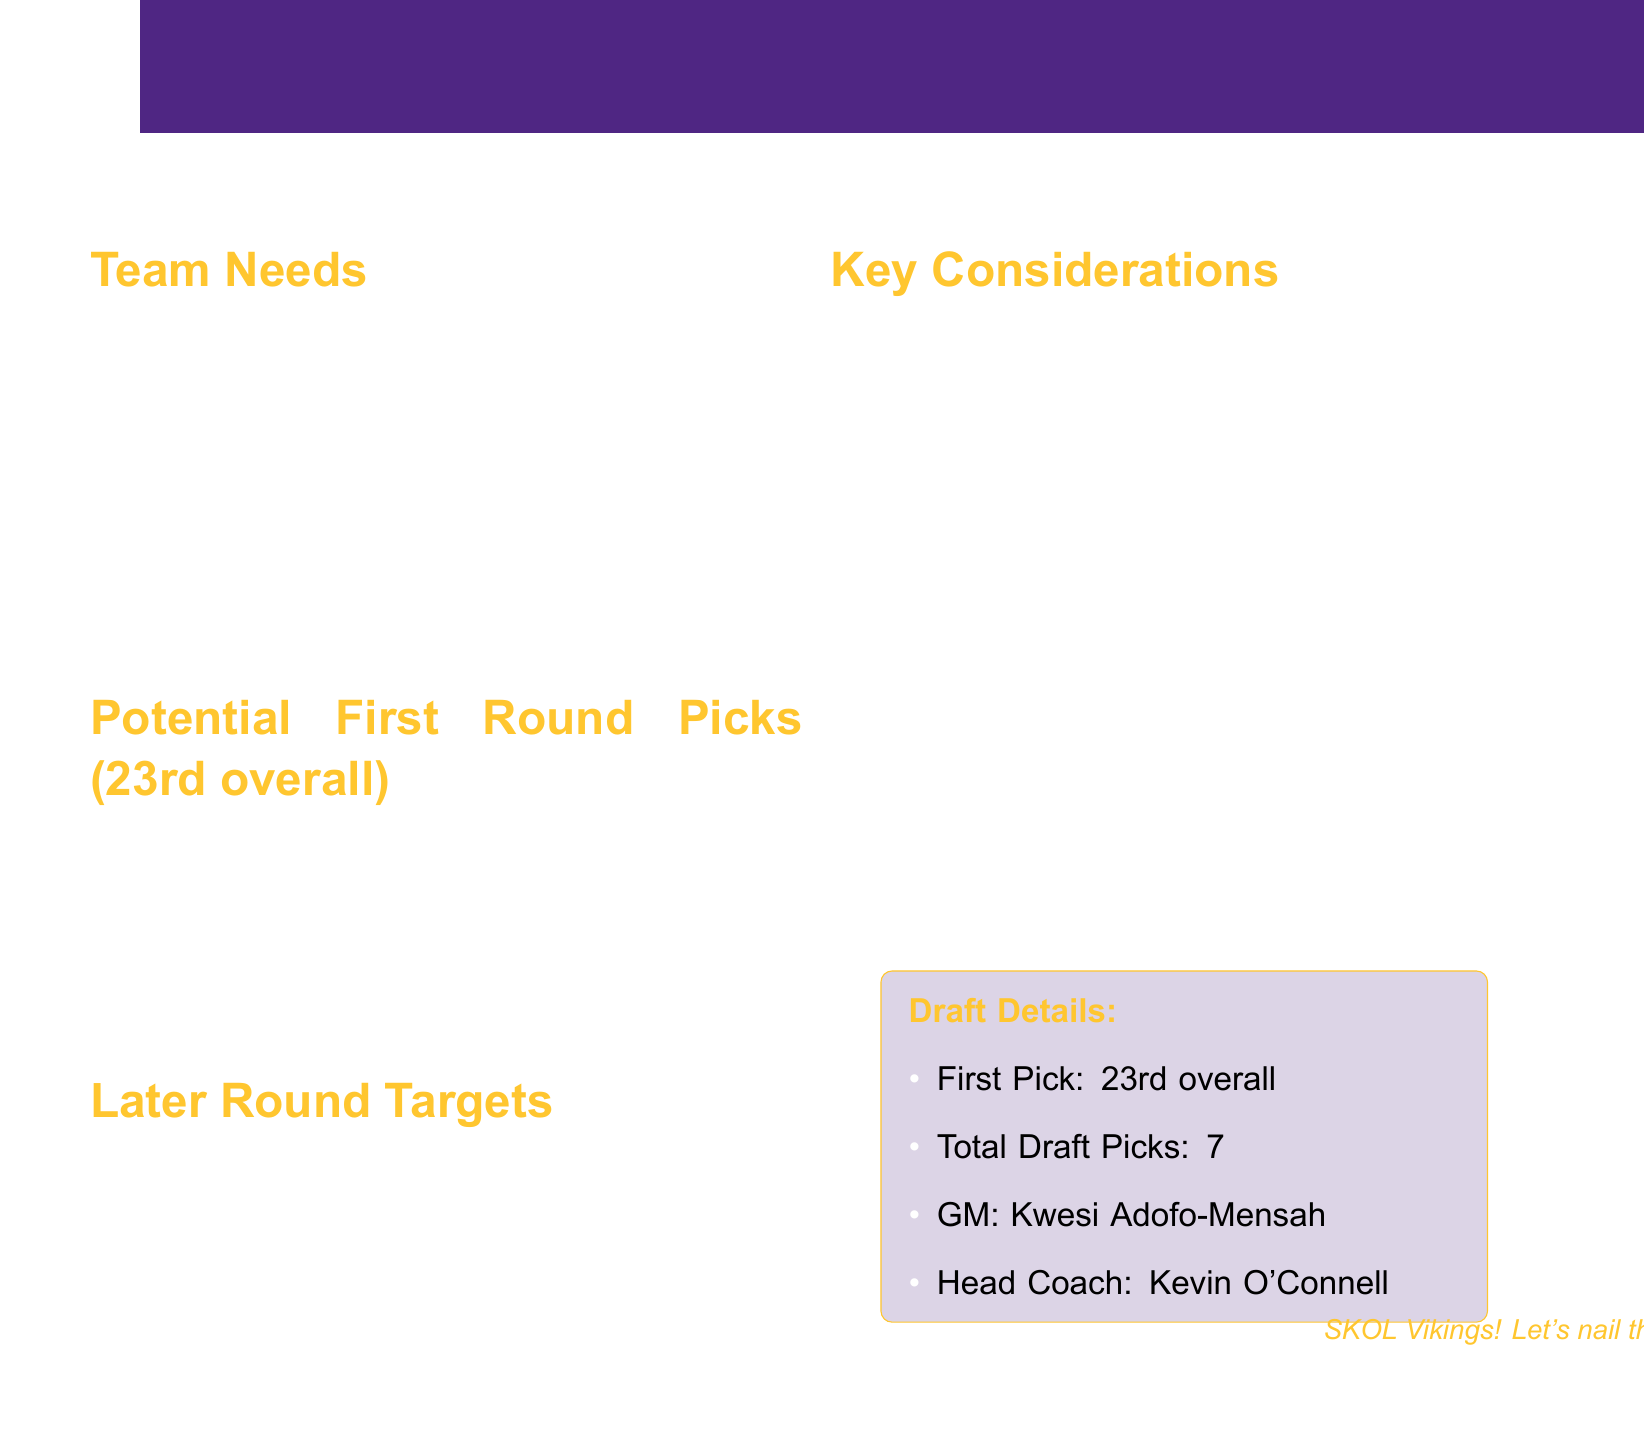What are the team needs? The document lists the top priorities for the Vikings, which include Cornerback, Wide Receiver, Interior Defensive Line, Edge Rusher, and Offensive Line depth.
Answer: Cornerback, Wide Receiver, Interior Defensive Line, Edge Rusher, Offensive Line depth Who is the General Manager? The General Manager overseeing the draft strategy is mentioned in the document.
Answer: Kwesi Adofo-Mensah What is the Vikings' first pick position in the draft? The document specifies the Vikings' first pick position in the upcoming draft.
Answer: 23rd overall Which player is mentioned as a potential wide receiver pick? The document lists specific players likely to be selected, including one who plays wide receiver.
Answer: Jaxon Smith-Njigba What key consideration involves Patrick Peterson? One of the important factors listed in the notes addresses the impact of a player's departure from the team.
Answer: Patrick Peterson's departure leaves a hole in secondary What is a later round target for the Vikings? The document identifies players that could be targeted in the later rounds, including one on the defensive line.
Answer: Zacch Pickens What is the total number of draft picks the Vikings have? The document states how many draft picks the Vikings will have in total for the upcoming draft.
Answer: 7 What position does Justin Jefferson play? The document implies the need for a complementary player for the position played by Justin Jefferson.
Answer: Wide Receiver 